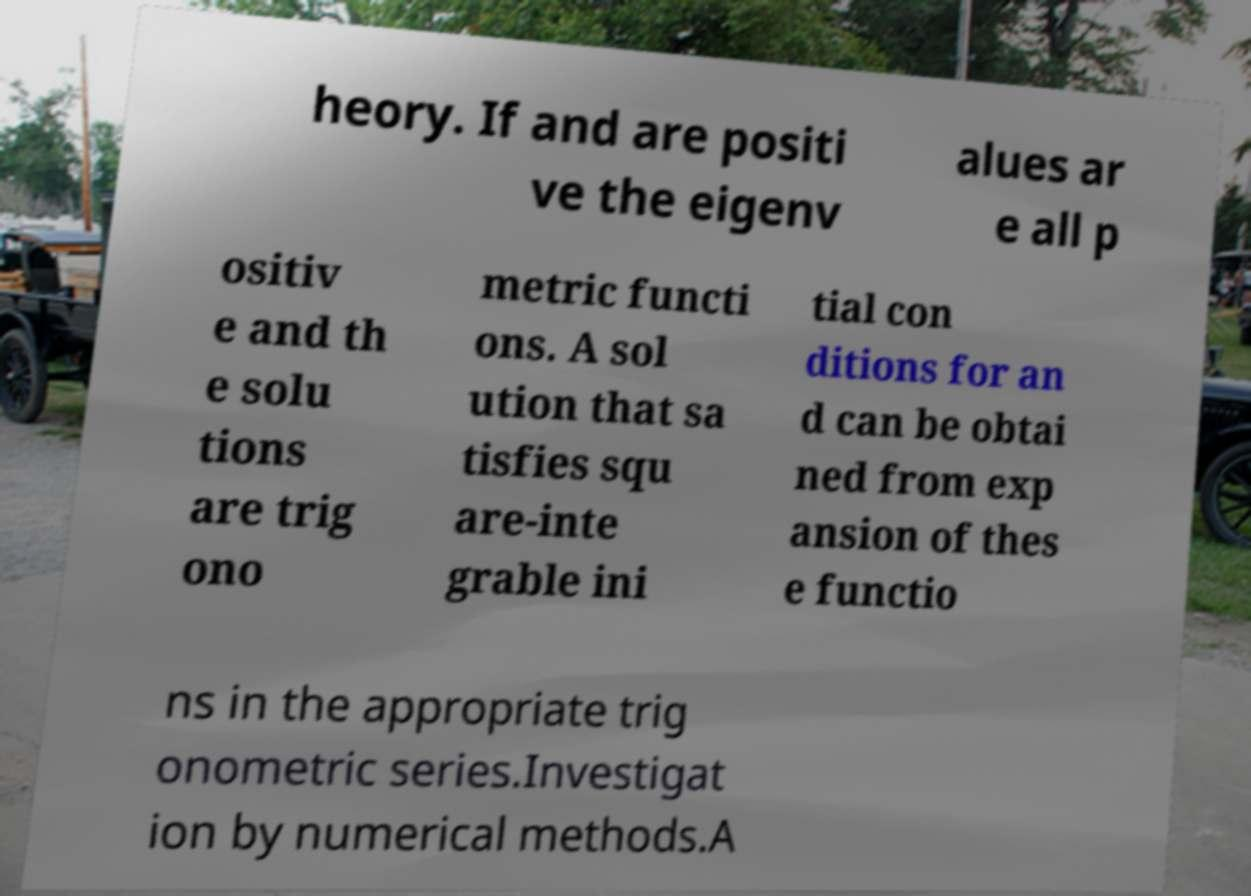Can you read and provide the text displayed in the image?This photo seems to have some interesting text. Can you extract and type it out for me? heory. If and are positi ve the eigenv alues ar e all p ositiv e and th e solu tions are trig ono metric functi ons. A sol ution that sa tisfies squ are-inte grable ini tial con ditions for an d can be obtai ned from exp ansion of thes e functio ns in the appropriate trig onometric series.Investigat ion by numerical methods.A 